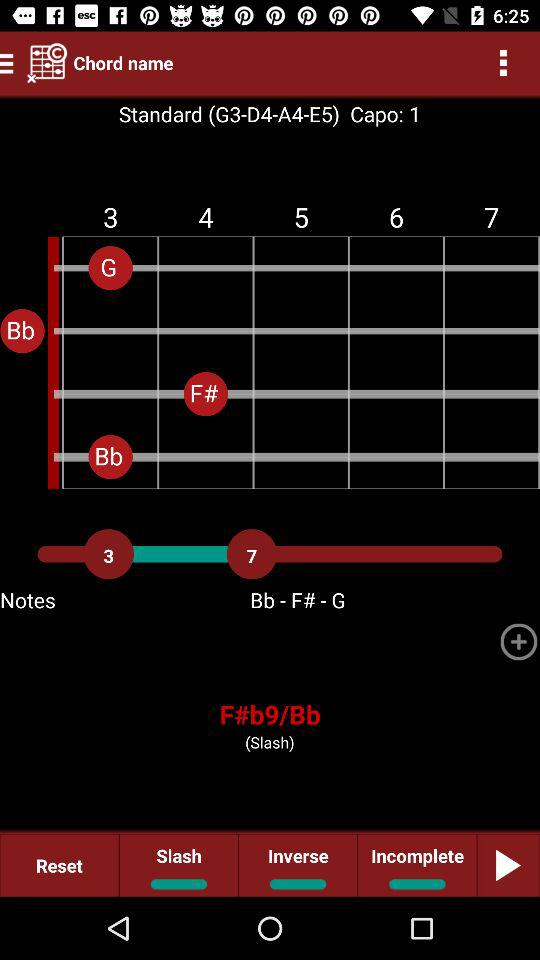What is the name of the chord that is highlighted?
Answer the question using a single word or phrase. F#b9/Bb 